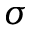<formula> <loc_0><loc_0><loc_500><loc_500>\sigma</formula> 